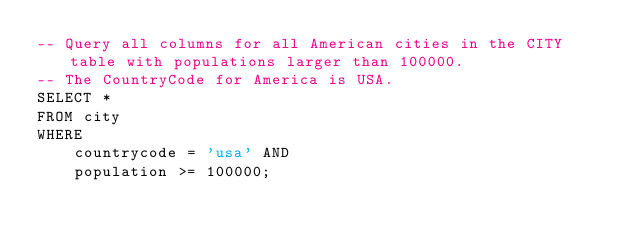<code> <loc_0><loc_0><loc_500><loc_500><_SQL_>-- Query all columns for all American cities in the CITY table with populations larger than 100000. 
-- The CountryCode for America is USA.
SELECT *
FROM city
WHERE 
    countrycode = 'usa' AND 
    population >= 100000;</code> 